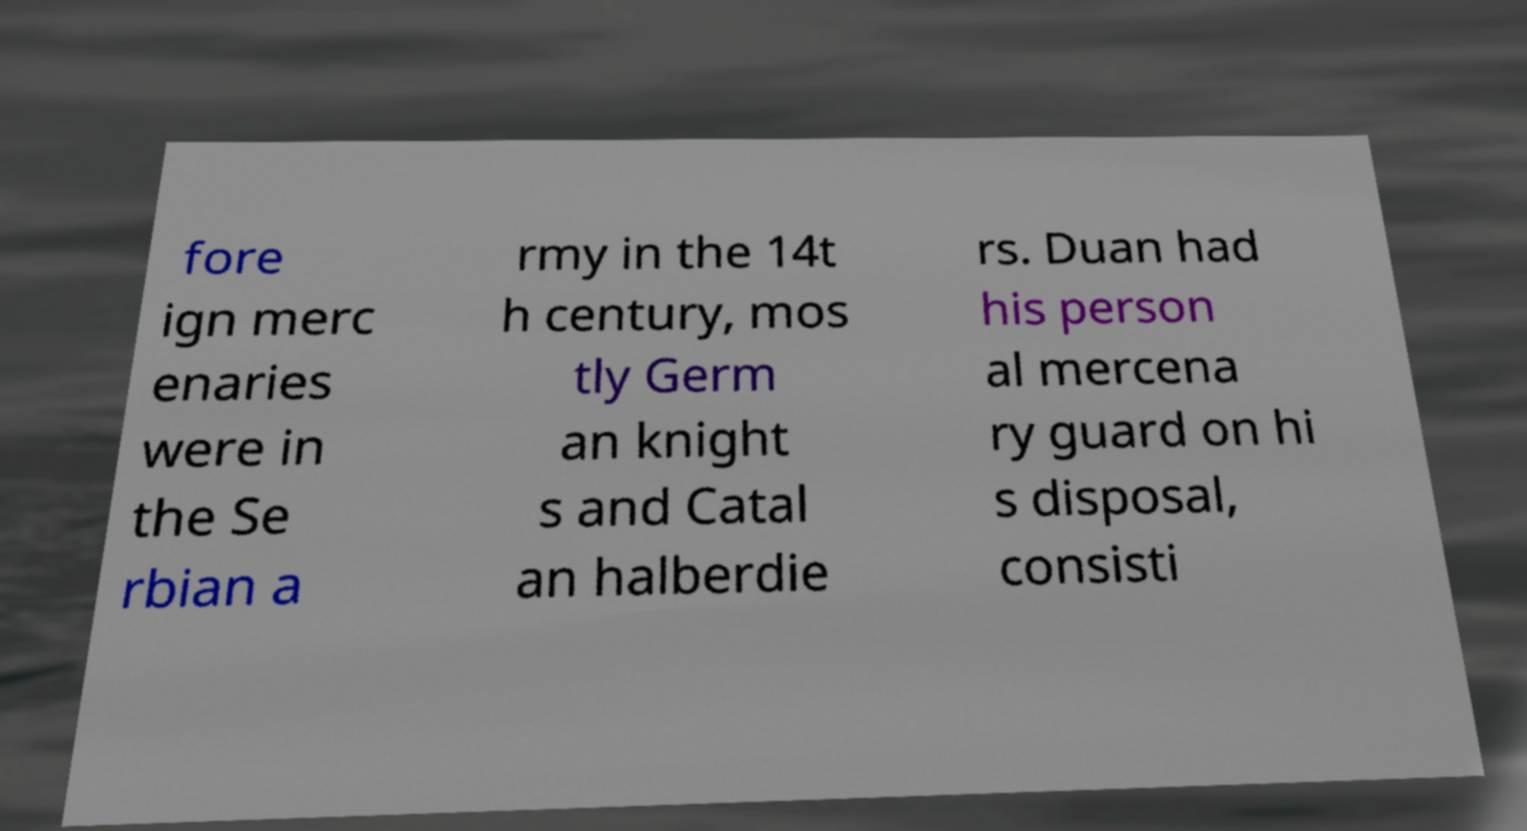There's text embedded in this image that I need extracted. Can you transcribe it verbatim? fore ign merc enaries were in the Se rbian a rmy in the 14t h century, mos tly Germ an knight s and Catal an halberdie rs. Duan had his person al mercena ry guard on hi s disposal, consisti 